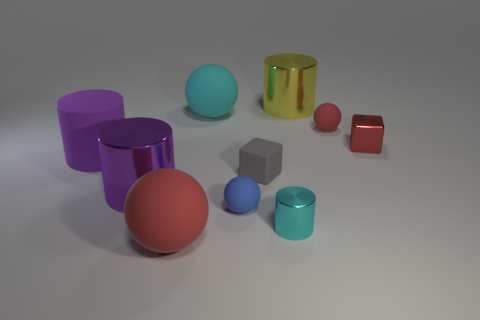Subtract 1 cylinders. How many cylinders are left? 3 Subtract all yellow cubes. Subtract all red cylinders. How many cubes are left? 2 Subtract all blocks. How many objects are left? 8 Subtract 0 cyan cubes. How many objects are left? 10 Subtract all purple rubber things. Subtract all tiny matte blocks. How many objects are left? 8 Add 6 large yellow metallic cylinders. How many large yellow metallic cylinders are left? 7 Add 2 big objects. How many big objects exist? 7 